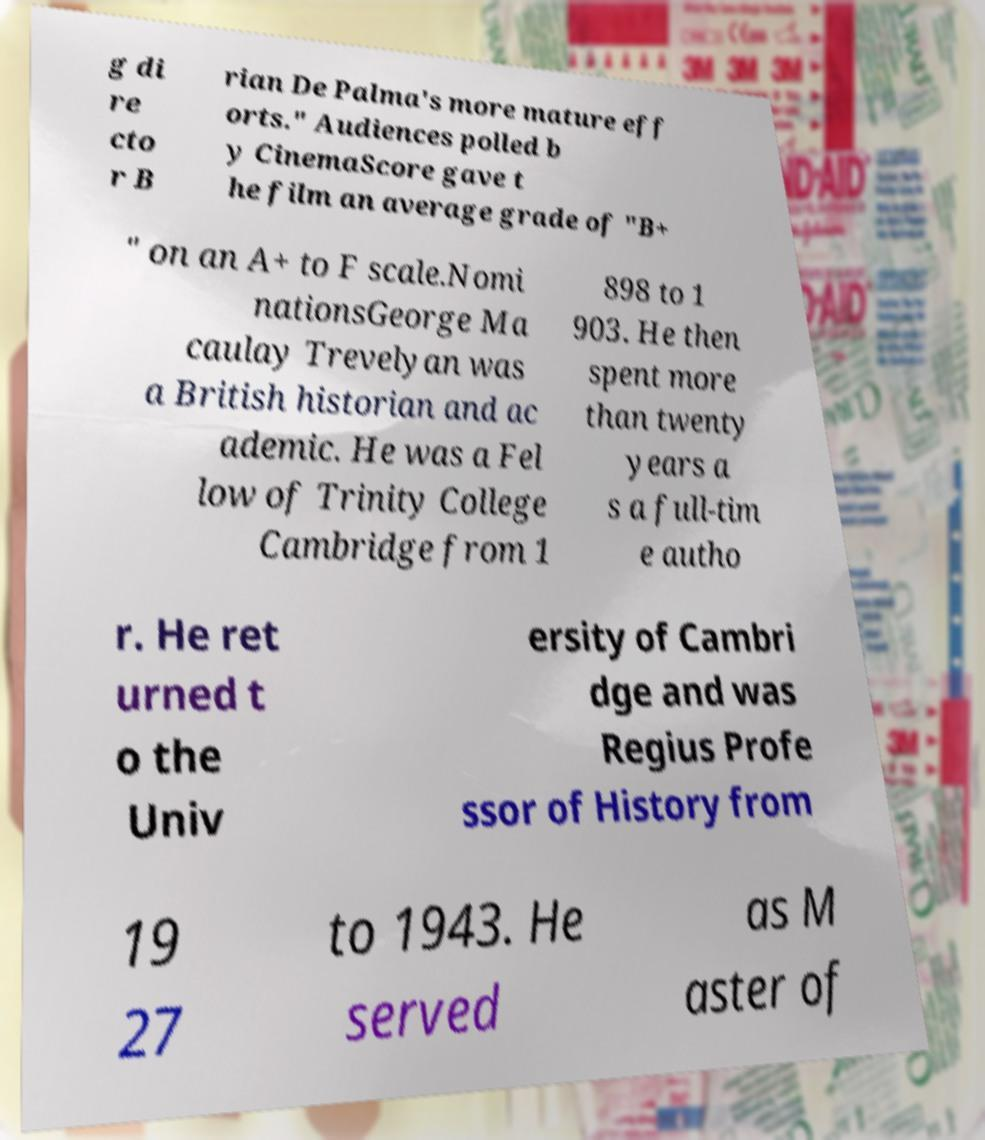Please identify and transcribe the text found in this image. g di re cto r B rian De Palma's more mature eff orts." Audiences polled b y CinemaScore gave t he film an average grade of "B+ " on an A+ to F scale.Nomi nationsGeorge Ma caulay Trevelyan was a British historian and ac ademic. He was a Fel low of Trinity College Cambridge from 1 898 to 1 903. He then spent more than twenty years a s a full-tim e autho r. He ret urned t o the Univ ersity of Cambri dge and was Regius Profe ssor of History from 19 27 to 1943. He served as M aster of 